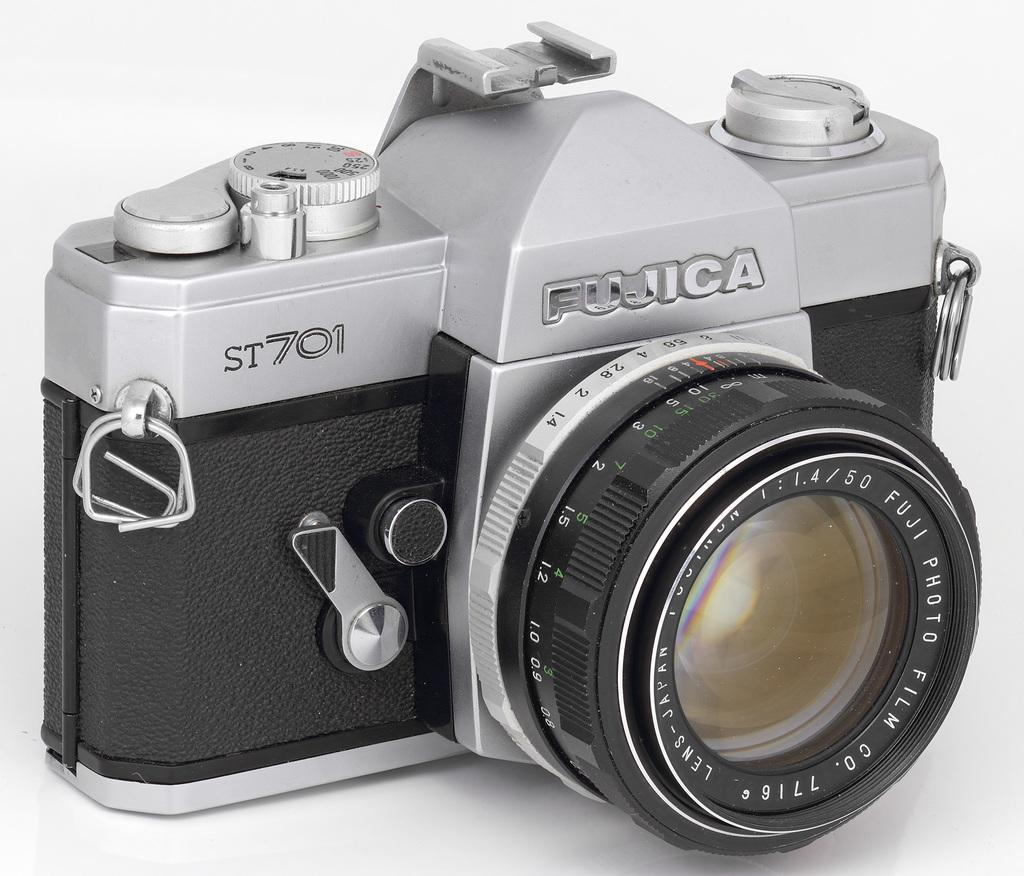<image>
Summarize the visual content of the image. A camera that is made by the company FUJICA. 